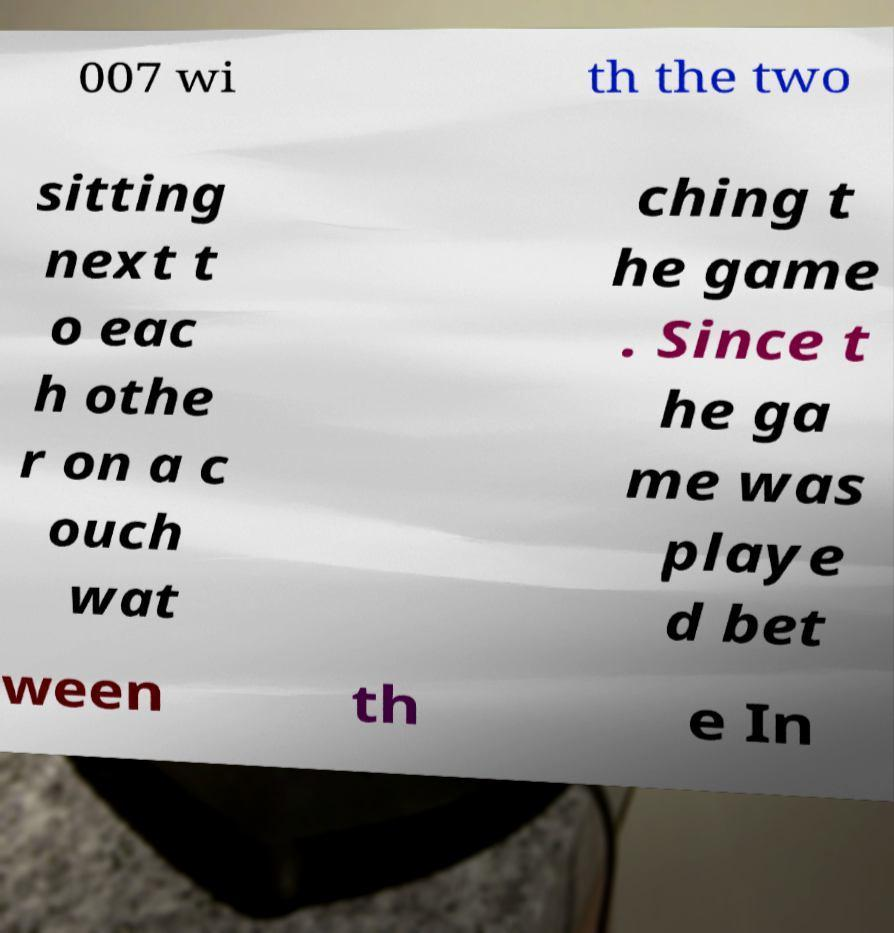Could you assist in decoding the text presented in this image and type it out clearly? 007 wi th the two sitting next t o eac h othe r on a c ouch wat ching t he game . Since t he ga me was playe d bet ween th e In 